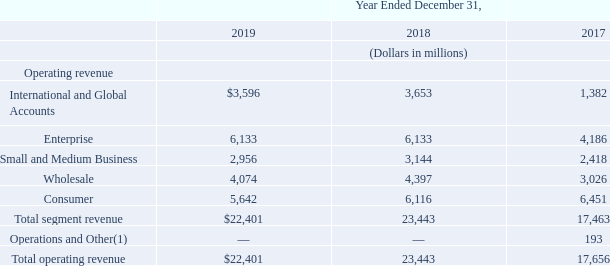Segment Results
General
Reconciliation of segment revenue to total operating revenue is below:
(1) On May 1, 2017 we sold a portion of our data centers and colocation business. See Note 3—Sale of Data Centers and Colocation Business to our consolidated financial statements in Item 8 of Part II of this report, for additional information.
What portion of business under Operations and Other was sold? Data centers and colocation business. What is the total segment revenue in 2019?
Answer scale should be: million. $22,401. What components are under operating revenue? International and global accounts, enterprise, small and medium business, wholesale, consumer. How many items are there under operating revenue? International and Global Accounts##Enterprise##Small and Medium Business##Wholesale##Consumer
Answer: 5. What is the difference between Wholesale and Consumer in 2019? 
Answer scale should be: million. 5,642-4,074
Answer: 1568. What is the percentage change in total operating revenue in 2019 from 2018?
Answer scale should be: percent. (22,401-23,443)/23,443
Answer: -4.44. 